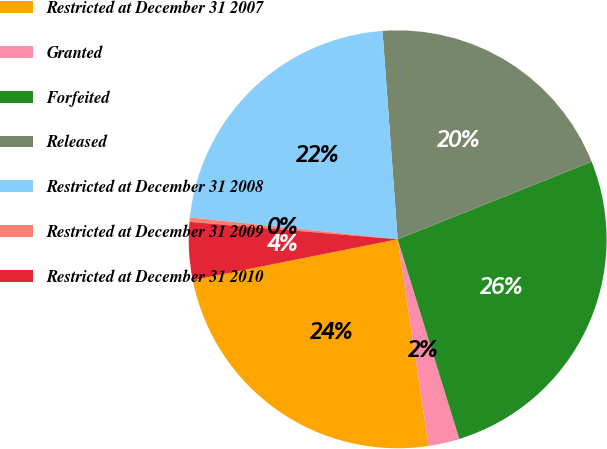Convert chart. <chart><loc_0><loc_0><loc_500><loc_500><pie_chart><fcel>Restricted at December 31 2007<fcel>Granted<fcel>Forfeited<fcel>Released<fcel>Restricted at December 31 2008<fcel>Restricted at December 31 2009<fcel>Restricted at December 31 2010<nl><fcel>24.23%<fcel>2.4%<fcel>26.29%<fcel>20.1%<fcel>22.17%<fcel>0.34%<fcel>4.47%<nl></chart> 